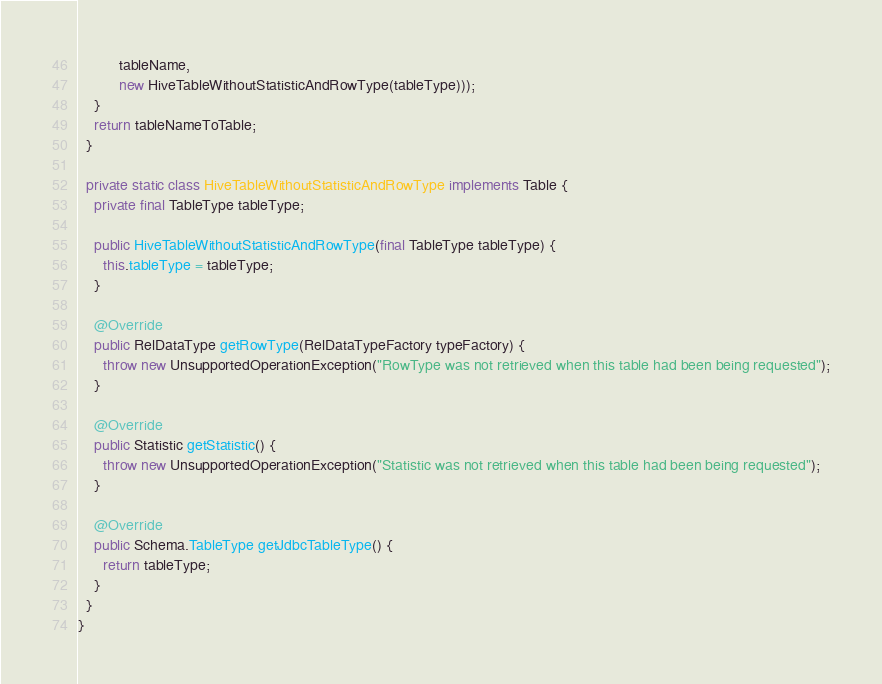Convert code to text. <code><loc_0><loc_0><loc_500><loc_500><_Java_>          tableName,
          new HiveTableWithoutStatisticAndRowType(tableType)));
    }
    return tableNameToTable;
  }

  private static class HiveTableWithoutStatisticAndRowType implements Table {
    private final TableType tableType;

    public HiveTableWithoutStatisticAndRowType(final TableType tableType) {
      this.tableType = tableType;
    }

    @Override
    public RelDataType getRowType(RelDataTypeFactory typeFactory) {
      throw new UnsupportedOperationException("RowType was not retrieved when this table had been being requested");
    }

    @Override
    public Statistic getStatistic() {
      throw new UnsupportedOperationException("Statistic was not retrieved when this table had been being requested");
    }

    @Override
    public Schema.TableType getJdbcTableType() {
      return tableType;
    }
  }
}
</code> 